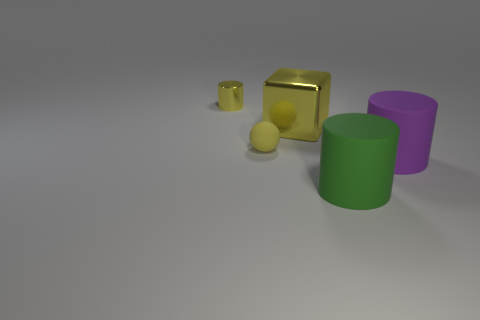Subtract all big purple matte cylinders. How many cylinders are left? 2 Add 1 balls. How many objects exist? 6 Subtract all cubes. How many objects are left? 4 Subtract 0 green spheres. How many objects are left? 5 Subtract all brown cylinders. Subtract all blue balls. How many cylinders are left? 3 Subtract all green blocks. Subtract all small metallic objects. How many objects are left? 4 Add 5 big rubber objects. How many big rubber objects are left? 7 Add 4 tiny blue rubber cylinders. How many tiny blue rubber cylinders exist? 4 